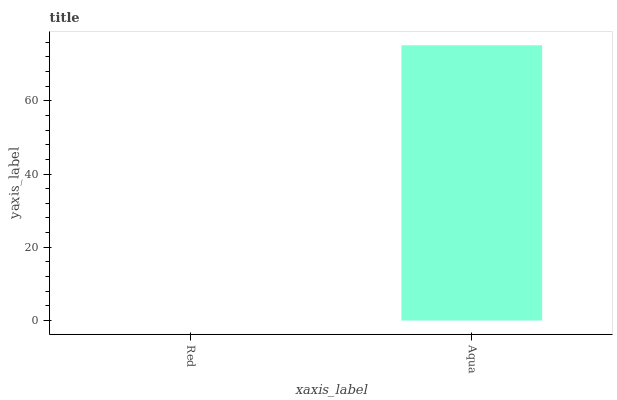Is Aqua the minimum?
Answer yes or no. No. Is Aqua greater than Red?
Answer yes or no. Yes. Is Red less than Aqua?
Answer yes or no. Yes. Is Red greater than Aqua?
Answer yes or no. No. Is Aqua less than Red?
Answer yes or no. No. Is Aqua the high median?
Answer yes or no. Yes. Is Red the low median?
Answer yes or no. Yes. Is Red the high median?
Answer yes or no. No. Is Aqua the low median?
Answer yes or no. No. 